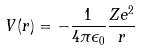Convert formula to latex. <formula><loc_0><loc_0><loc_500><loc_500>V ( r ) = - \frac { 1 } { 4 \pi \epsilon _ { 0 } } \frac { Z e ^ { 2 } } { r }</formula> 